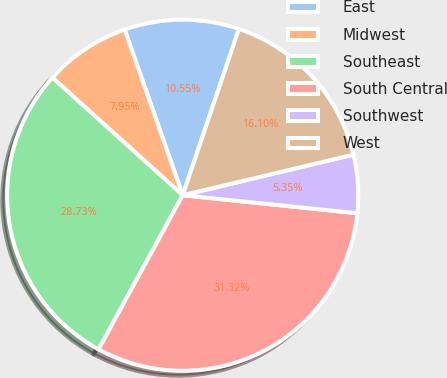Convert chart to OTSL. <chart><loc_0><loc_0><loc_500><loc_500><pie_chart><fcel>East<fcel>Midwest<fcel>Southeast<fcel>South Central<fcel>Southwest<fcel>West<nl><fcel>10.55%<fcel>7.95%<fcel>28.73%<fcel>31.32%<fcel>5.35%<fcel>16.1%<nl></chart> 